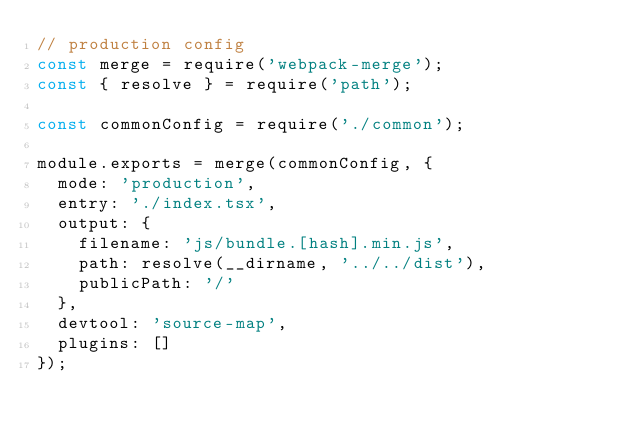<code> <loc_0><loc_0><loc_500><loc_500><_JavaScript_>// production config
const merge = require('webpack-merge');
const { resolve } = require('path');

const commonConfig = require('./common');

module.exports = merge(commonConfig, {
  mode: 'production',
  entry: './index.tsx',
  output: {
    filename: 'js/bundle.[hash].min.js',
    path: resolve(__dirname, '../../dist'),
    publicPath: '/'
  },
  devtool: 'source-map',
  plugins: []
});
</code> 